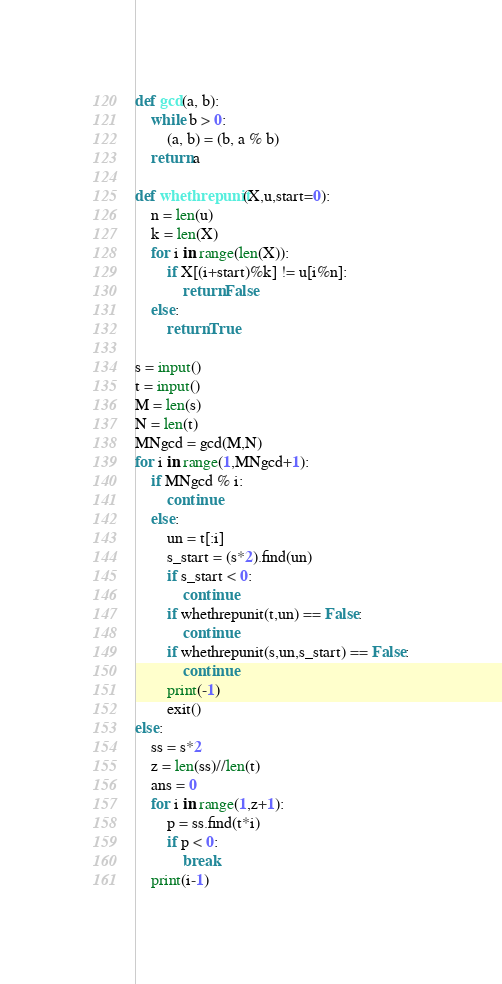<code> <loc_0><loc_0><loc_500><loc_500><_Python_>def gcd(a, b):
    while b > 0:
        (a, b) = (b, a % b)
    return a

def whethrepunit(X,u,start=0):
    n = len(u)
    k = len(X)
    for i in range(len(X)):
        if X[(i+start)%k] != u[i%n]:
            return False
    else:
        return True

s = input()
t = input()
M = len(s)
N = len(t)
MNgcd = gcd(M,N)
for i in range(1,MNgcd+1):
    if MNgcd % i:
        continue
    else:
        un = t[:i]
        s_start = (s*2).find(un)
        if s_start < 0:
            continue
        if whethrepunit(t,un) == False:
            continue
        if whethrepunit(s,un,s_start) == False:
            continue
        print(-1)
        exit()
else:
    ss = s*2
    z = len(ss)//len(t)
    ans = 0
    for i in range(1,z+1):
        p = ss.find(t*i)
        if p < 0:
            break
    print(i-1)</code> 